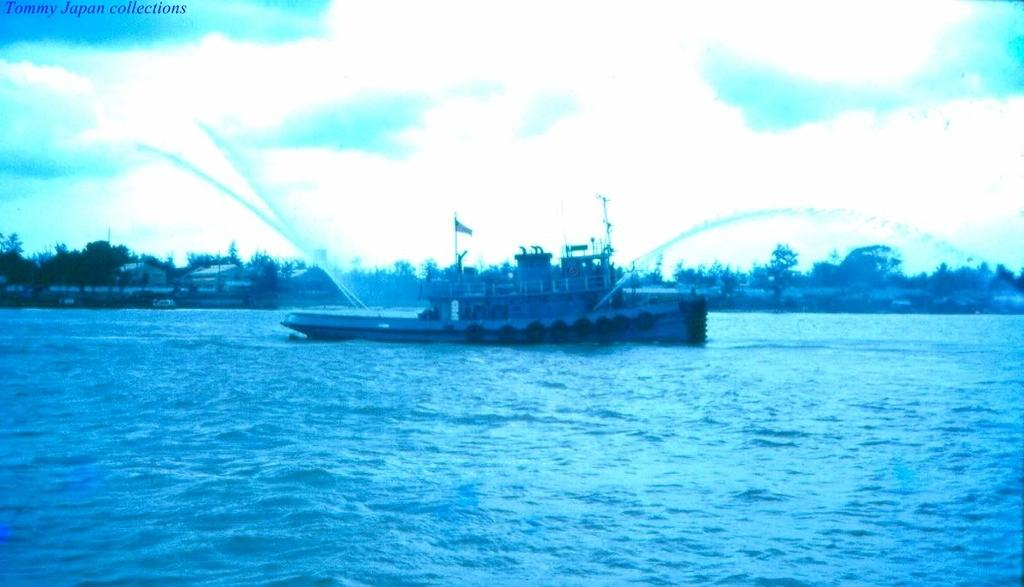What is the main subject of the image? The main subject of the image is a ship. Where is the ship located? The ship is in a lake. What is the ship doing in the image? The ship is spraying water into the lake. What can be seen in the background of the image? There are buildings and trees in the background of the image. What type of iron is being used to create sparks in the image? There is no iron or sparks present in the image; it features a ship in a lake spraying water. 